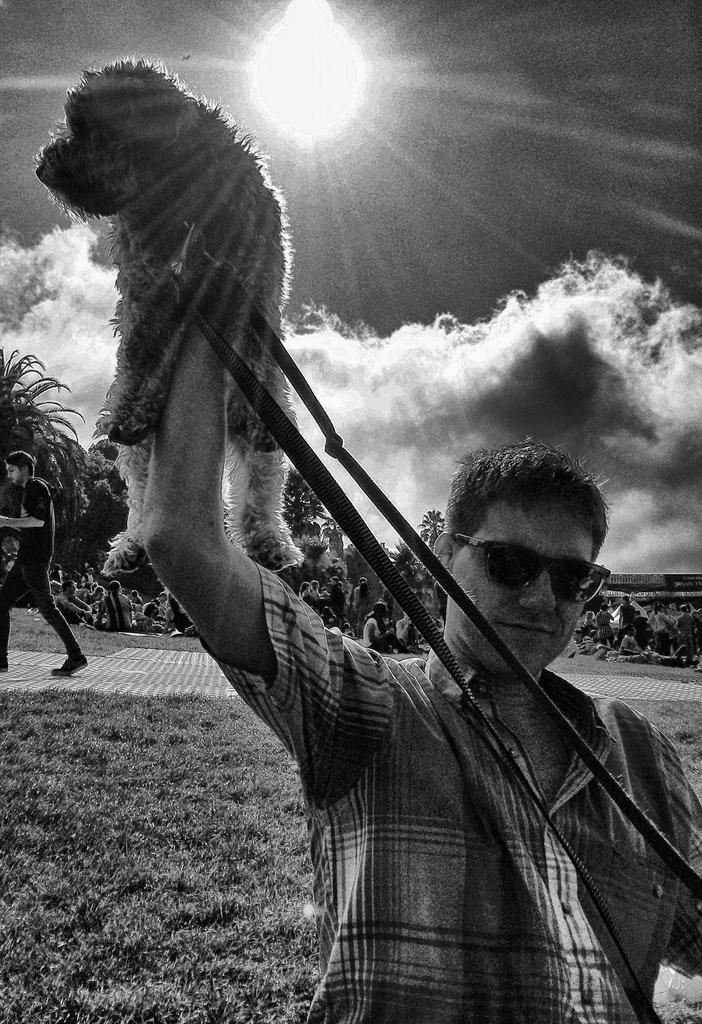In one or two sentences, can you explain what this image depicts? In this image I can see a man in the front and I can see he is holding a dog. I can see he is wearing a shirt, shades and in the front of him I can see dog's leash. In the background I can see an open grass ground and on it I can see number of people where few are standing and rest all are sitting. I can also see few trees, clouds, the sky and the sun in the background. I can see this image is black and white in color. 